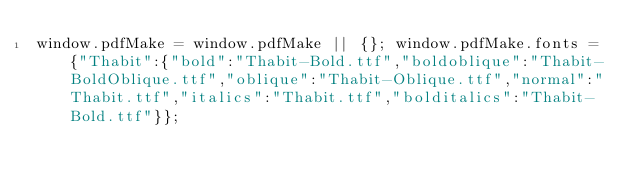<code> <loc_0><loc_0><loc_500><loc_500><_JavaScript_>window.pdfMake = window.pdfMake || {}; window.pdfMake.fonts = {"Thabit":{"bold":"Thabit-Bold.ttf","boldoblique":"Thabit-BoldOblique.ttf","oblique":"Thabit-Oblique.ttf","normal":"Thabit.ttf","italics":"Thabit.ttf","bolditalics":"Thabit-Bold.ttf"}};</code> 